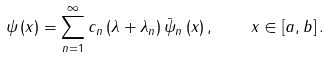Convert formula to latex. <formula><loc_0><loc_0><loc_500><loc_500>\psi \left ( x \right ) = \sum _ { n = 1 } ^ { \infty } c _ { n } \left ( \lambda + \lambda _ { n } \right ) \bar { \psi } _ { n } \left ( x \right ) , \quad x \in \left [ a , b \right ] .</formula> 